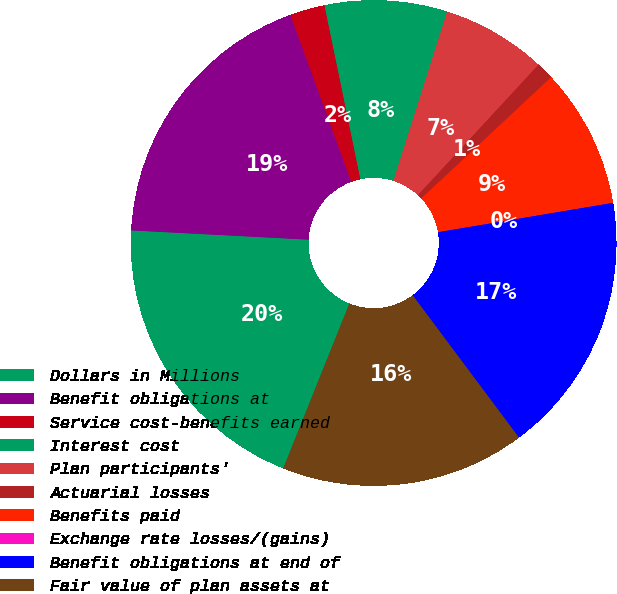Convert chart to OTSL. <chart><loc_0><loc_0><loc_500><loc_500><pie_chart><fcel>Dollars in Millions<fcel>Benefit obligations at<fcel>Service cost-benefits earned<fcel>Interest cost<fcel>Plan participants'<fcel>Actuarial losses<fcel>Benefits paid<fcel>Exchange rate losses/(gains)<fcel>Benefit obligations at end of<fcel>Fair value of plan assets at<nl><fcel>19.76%<fcel>18.6%<fcel>2.33%<fcel>8.14%<fcel>6.98%<fcel>1.17%<fcel>9.3%<fcel>0.01%<fcel>17.44%<fcel>16.28%<nl></chart> 